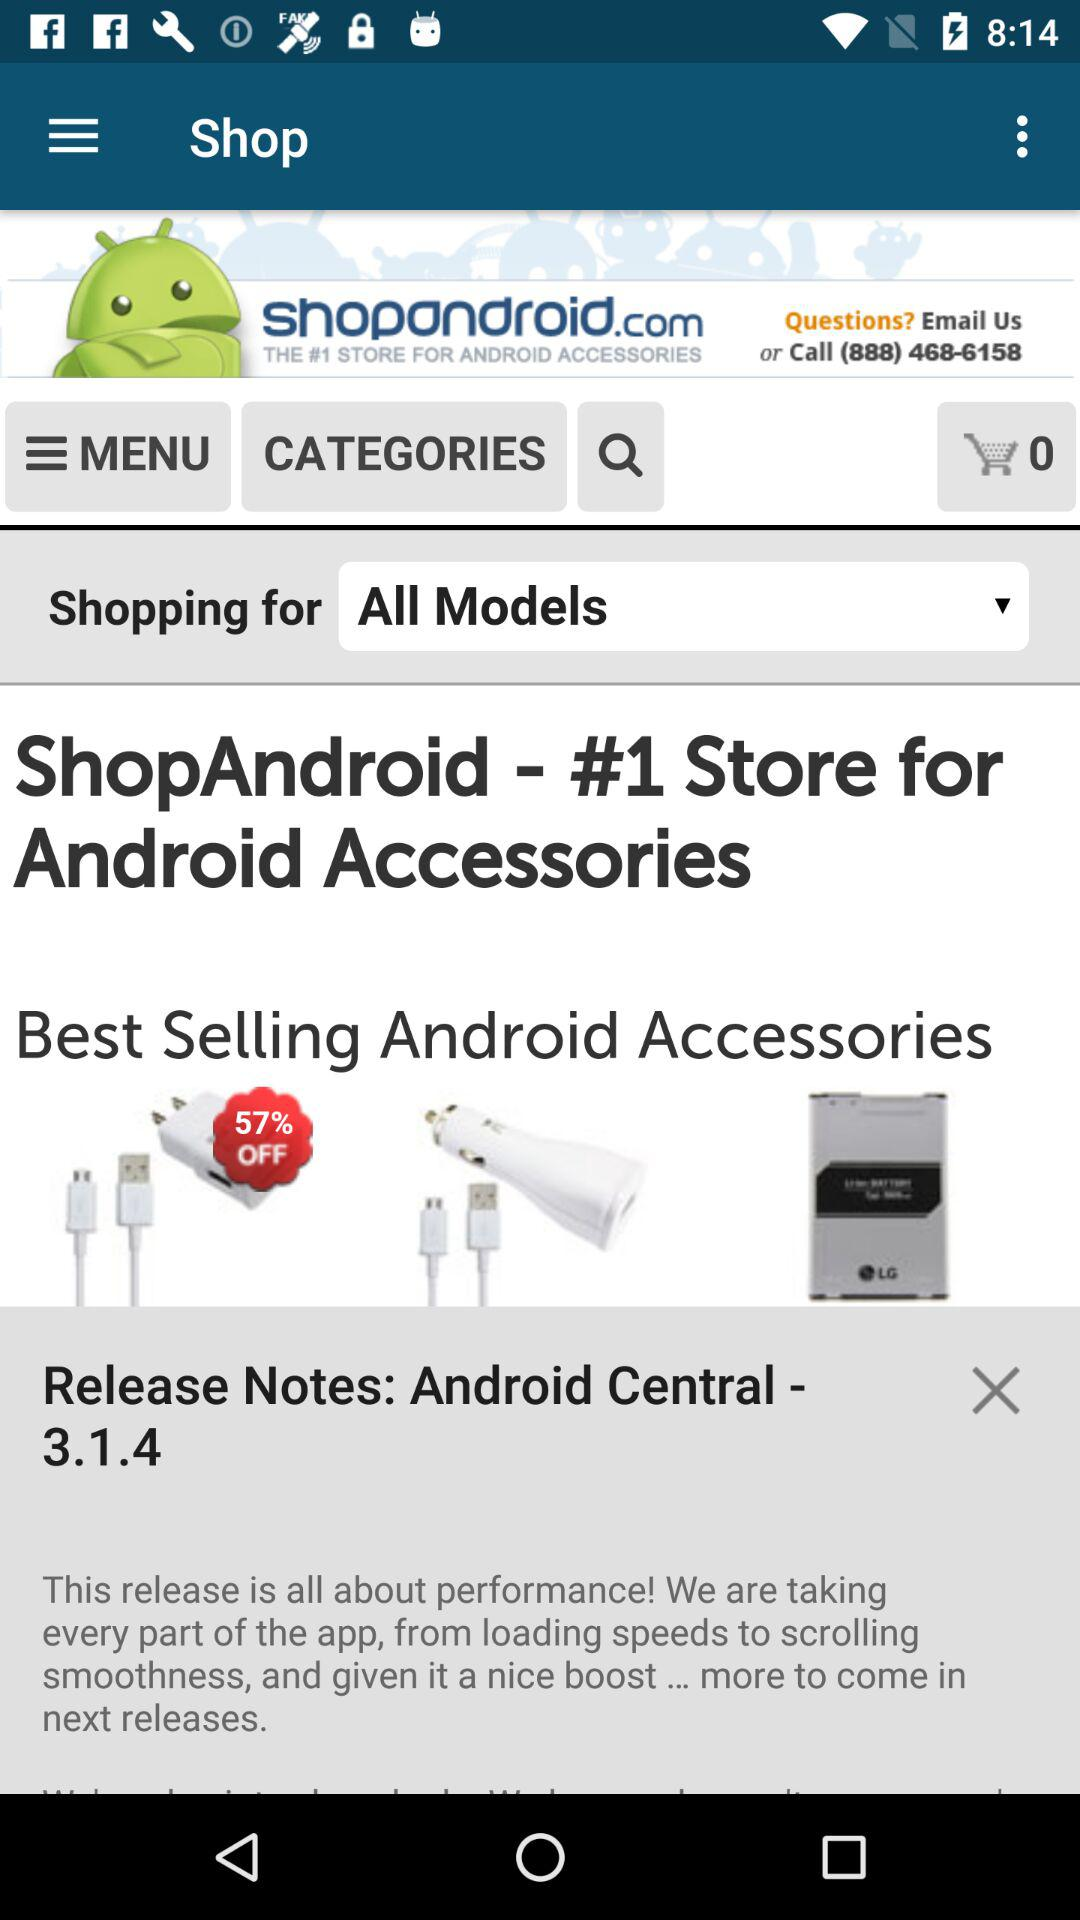How many categories are there?
When the provided information is insufficient, respond with <no answer>. <no answer> 